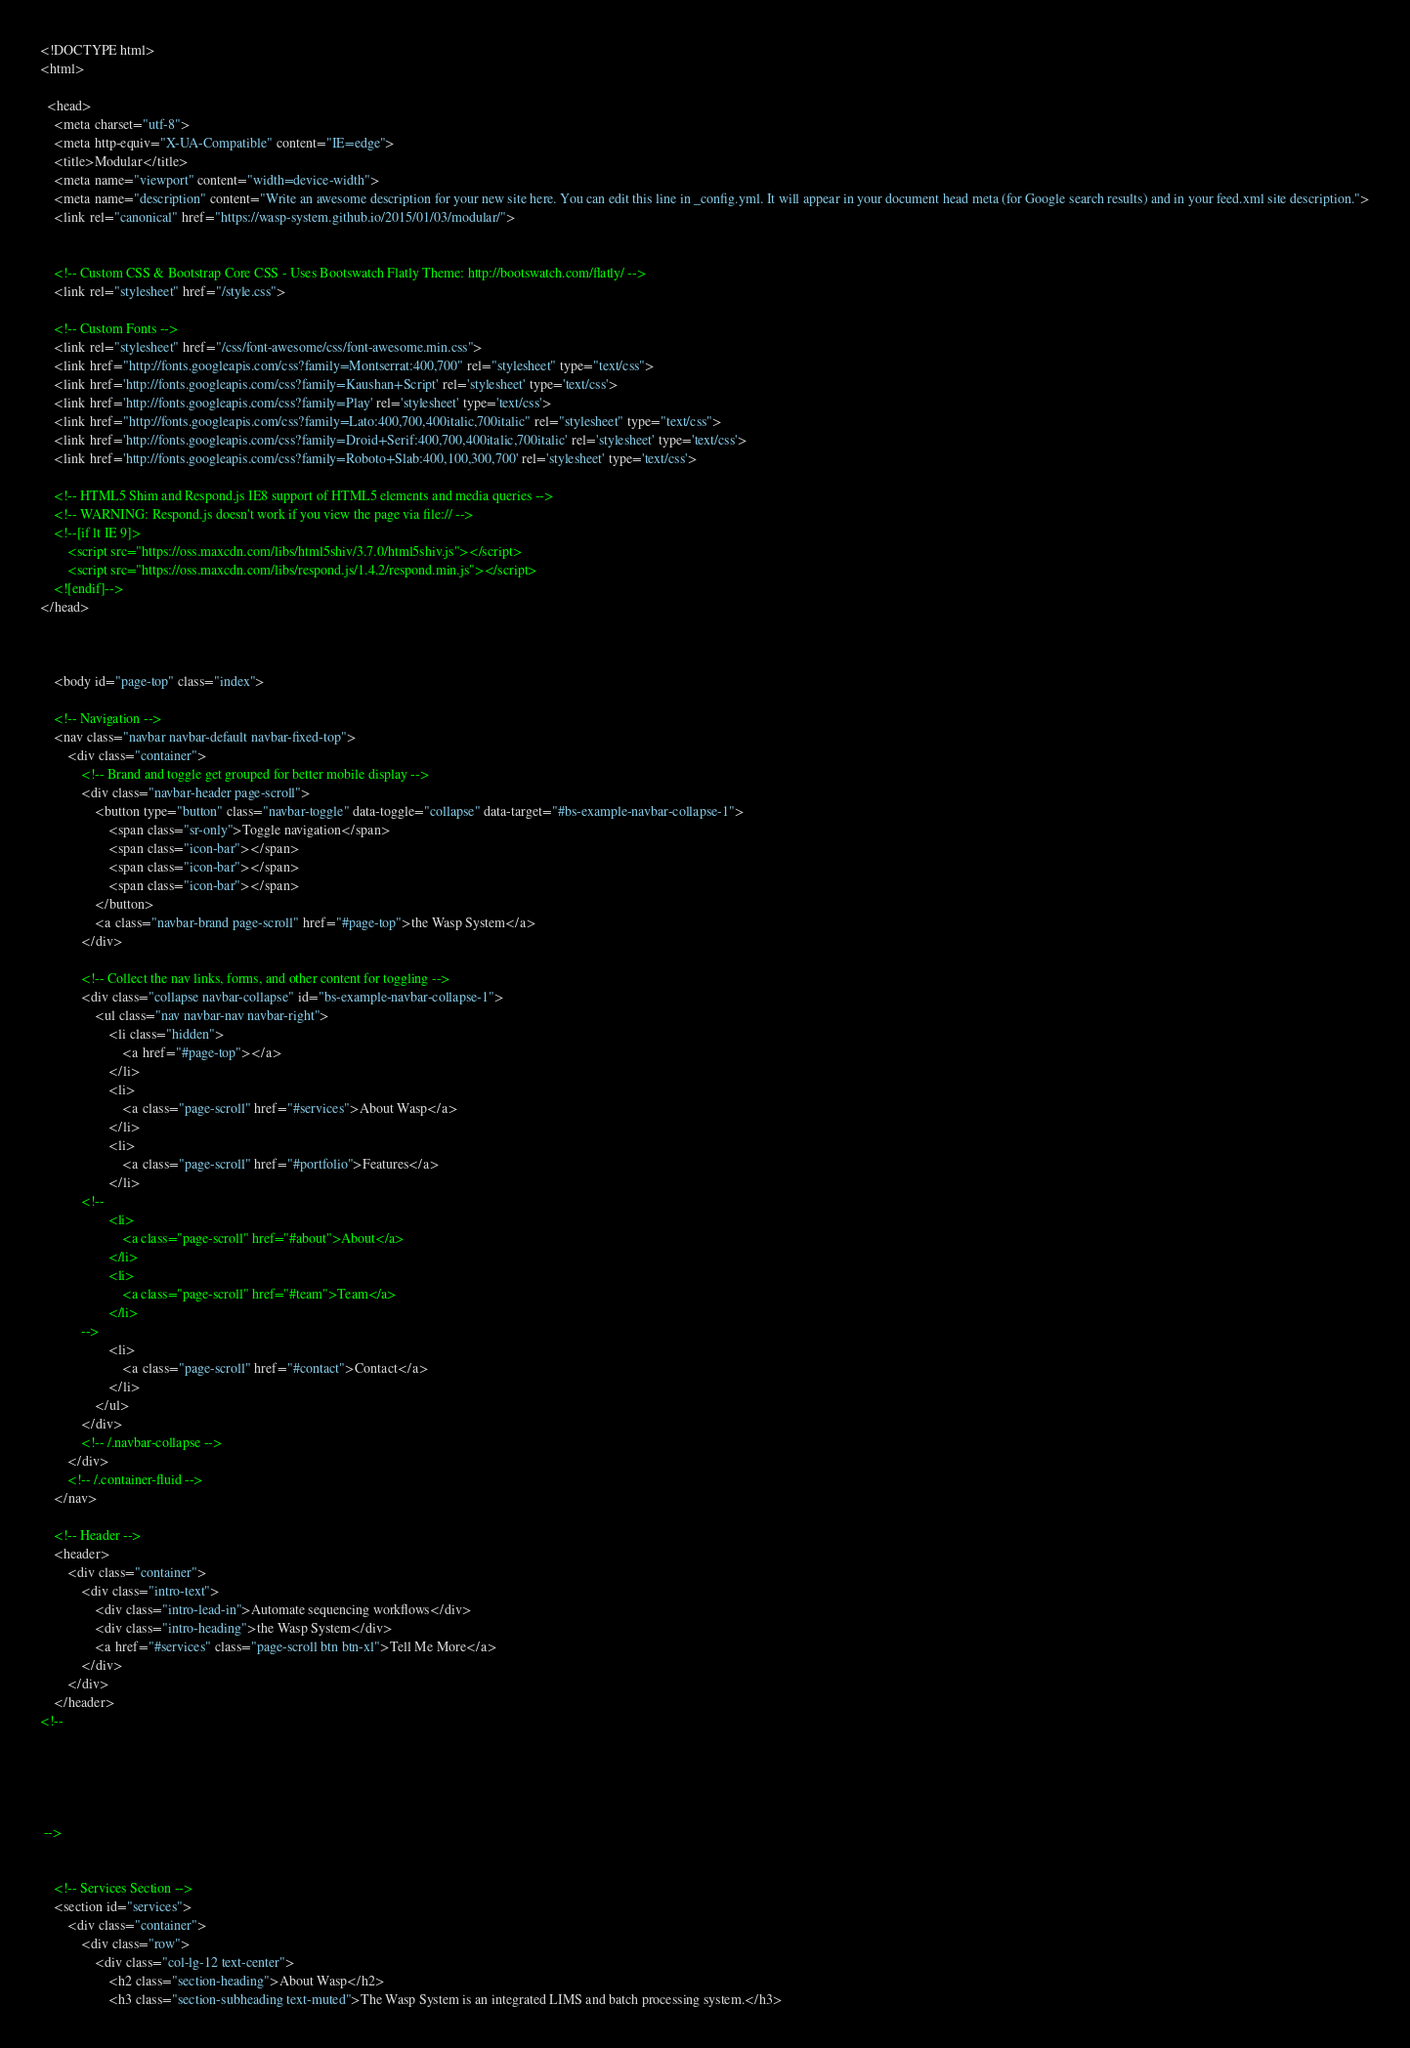<code> <loc_0><loc_0><loc_500><loc_500><_HTML_><!DOCTYPE html>
<html>

  <head>
    <meta charset="utf-8">
    <meta http-equiv="X-UA-Compatible" content="IE=edge">
    <title>Modular</title>
    <meta name="viewport" content="width=device-width">
    <meta name="description" content="Write an awesome description for your new site here. You can edit this line in _config.yml. It will appear in your document head meta (for Google search results) and in your feed.xml site description.">
    <link rel="canonical" href="https://wasp-system.github.io/2015/01/03/modular/">


    <!-- Custom CSS & Bootstrap Core CSS - Uses Bootswatch Flatly Theme: http://bootswatch.com/flatly/ -->
    <link rel="stylesheet" href="/style.css">

    <!-- Custom Fonts -->
    <link rel="stylesheet" href="/css/font-awesome/css/font-awesome.min.css">
    <link href="http://fonts.googleapis.com/css?family=Montserrat:400,700" rel="stylesheet" type="text/css">
    <link href='http://fonts.googleapis.com/css?family=Kaushan+Script' rel='stylesheet' type='text/css'>
    <link href='http://fonts.googleapis.com/css?family=Play' rel='stylesheet' type='text/css'>
    <link href="http://fonts.googleapis.com/css?family=Lato:400,700,400italic,700italic" rel="stylesheet" type="text/css">
    <link href='http://fonts.googleapis.com/css?family=Droid+Serif:400,700,400italic,700italic' rel='stylesheet' type='text/css'>
    <link href='http://fonts.googleapis.com/css?family=Roboto+Slab:400,100,300,700' rel='stylesheet' type='text/css'>

    <!-- HTML5 Shim and Respond.js IE8 support of HTML5 elements and media queries -->
    <!-- WARNING: Respond.js doesn't work if you view the page via file:// -->
    <!--[if lt IE 9]>
        <script src="https://oss.maxcdn.com/libs/html5shiv/3.7.0/html5shiv.js"></script>
        <script src="https://oss.maxcdn.com/libs/respond.js/1.4.2/respond.min.js"></script>
    <![endif]-->
</head>



    <body id="page-top" class="index">

    <!-- Navigation -->
    <nav class="navbar navbar-default navbar-fixed-top">
        <div class="container">
            <!-- Brand and toggle get grouped for better mobile display -->
            <div class="navbar-header page-scroll">
                <button type="button" class="navbar-toggle" data-toggle="collapse" data-target="#bs-example-navbar-collapse-1">
                    <span class="sr-only">Toggle navigation</span>
                    <span class="icon-bar"></span>
                    <span class="icon-bar"></span>
                    <span class="icon-bar"></span>
                </button>
                <a class="navbar-brand page-scroll" href="#page-top">the Wasp System</a>
            </div>

            <!-- Collect the nav links, forms, and other content for toggling -->
            <div class="collapse navbar-collapse" id="bs-example-navbar-collapse-1">
                <ul class="nav navbar-nav navbar-right">
                    <li class="hidden">
                        <a href="#page-top"></a>
                    </li>
                    <li>
                        <a class="page-scroll" href="#services">About Wasp</a>
                    </li>
                    <li>
                        <a class="page-scroll" href="#portfolio">Features</a>
                    </li>
		    <!--
                    <li>
                        <a class="page-scroll" href="#about">About</a>
                    </li>
                    <li>
                        <a class="page-scroll" href="#team">Team</a>
                    </li>
		    -->
                    <li>
                        <a class="page-scroll" href="#contact">Contact</a>
                    </li>
                </ul>
            </div>
            <!-- /.navbar-collapse -->
        </div>
        <!-- /.container-fluid -->
    </nav>

    <!-- Header -->
    <header>
        <div class="container">
            <div class="intro-text">
                <div class="intro-lead-in">Automate sequencing workflows</div>
                <div class="intro-heading">the Wasp System</div>
                <a href="#services" class="page-scroll btn btn-xl">Tell Me More</a>
            </div>
        </div>
    </header>
<!--
        
          
        
          
        
 -->


    <!-- Services Section -->
    <section id="services">
        <div class="container">
            <div class="row">
                <div class="col-lg-12 text-center">
                    <h2 class="section-heading">About Wasp</h2>
                    <h3 class="section-subheading text-muted">The Wasp System is an integrated LIMS and batch processing system.</h3></code> 